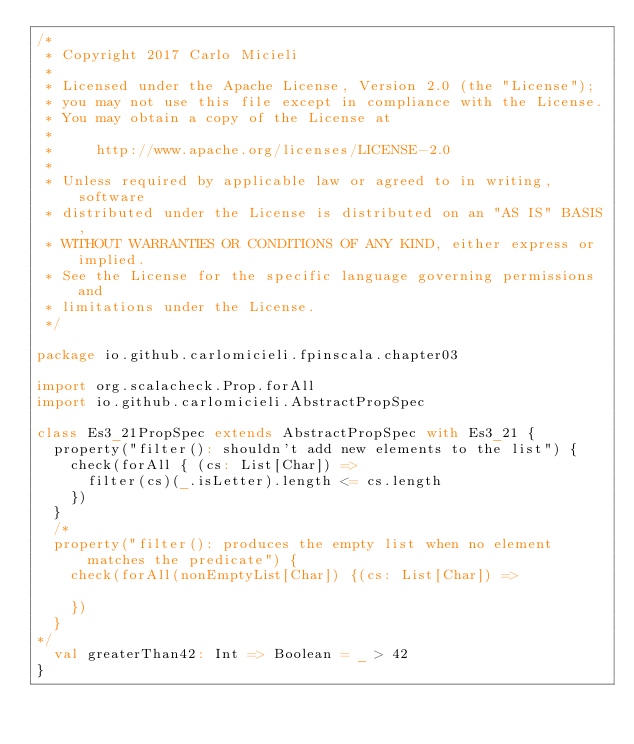<code> <loc_0><loc_0><loc_500><loc_500><_Scala_>/*
 * Copyright 2017 Carlo Micieli
 *
 * Licensed under the Apache License, Version 2.0 (the "License");
 * you may not use this file except in compliance with the License.
 * You may obtain a copy of the License at
 *
 *     http://www.apache.org/licenses/LICENSE-2.0
 *
 * Unless required by applicable law or agreed to in writing, software
 * distributed under the License is distributed on an "AS IS" BASIS,
 * WITHOUT WARRANTIES OR CONDITIONS OF ANY KIND, either express or implied.
 * See the License for the specific language governing permissions and
 * limitations under the License.
 */

package io.github.carlomicieli.fpinscala.chapter03

import org.scalacheck.Prop.forAll
import io.github.carlomicieli.AbstractPropSpec

class Es3_21PropSpec extends AbstractPropSpec with Es3_21 {
  property("filter(): shouldn't add new elements to the list") {
    check(forAll { (cs: List[Char]) =>
      filter(cs)(_.isLetter).length <= cs.length
    })
  }
  /*
  property("filter(): produces the empty list when no element matches the predicate") {
    check(forAll(nonEmptyList[Char]) {(cs: List[Char]) =>

    })
  }
*/
  val greaterThan42: Int => Boolean = _ > 42
}
</code> 